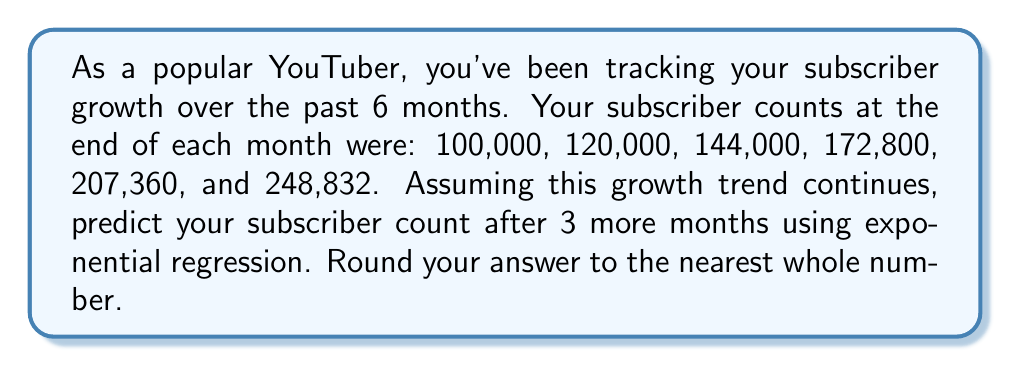Teach me how to tackle this problem. To solve this problem, we'll use exponential regression to model the subscriber growth and then predict the future subscriber count.

1) First, let's identify our data points:
   Month (x): 0, 1, 2, 3, 4, 5
   Subscribers (y): 100000, 120000, 144000, 172800, 207360, 248832

2) The exponential model has the form $y = ab^x$, where $a$ is the initial value and $b$ is the growth factor.

3) To find $a$ and $b$, we'll linearize the equation by taking logarithms:
   $\ln(y) = \ln(a) + x\ln(b)$

4) Let $Y = \ln(y)$, $A = \ln(a)$, and $B = \ln(b)$. Then we have:
   $Y = A + Bx$

5) We can now use linear regression. The formulas for $B$ and $A$ are:
   $$B = \frac{n\sum(xY) - \sum x \sum Y}{n\sum x^2 - (\sum x)^2}$$
   $$A = \bar{Y} - B\bar{x}$$

6) Calculating the necessary sums:
   $\sum x = 15$, $\sum x^2 = 55$, $n = 6$
   $\sum Y = 73.5718$, $\sum(xY) = 254.7054$

7) Plugging into the formula for $B$:
   $$B = \frac{6(254.7054) - 15(73.5718)}{6(55) - 15^2} = 0.1823$$

8) Calculating $\bar{x} = 2.5$ and $\bar{Y} = 12.2620$, we can find $A$:
   $$A = 12.2620 - 0.1823(2.5) = 11.8062$$

9) Now we have $Y = 11.8062 + 0.1823x$. Converting back to the original form:
   $y = e^{11.8062} \cdot (e^{0.1823})^x = 133783.33 \cdot (1.2)^x$

10) To predict the subscriber count after 3 more months, we substitute $x = 8$:
    $y = 133783.33 \cdot (1.2)^8 = 429156.84$

11) Rounding to the nearest whole number, we get 429,157 subscribers.
Answer: 429,157 subscribers 